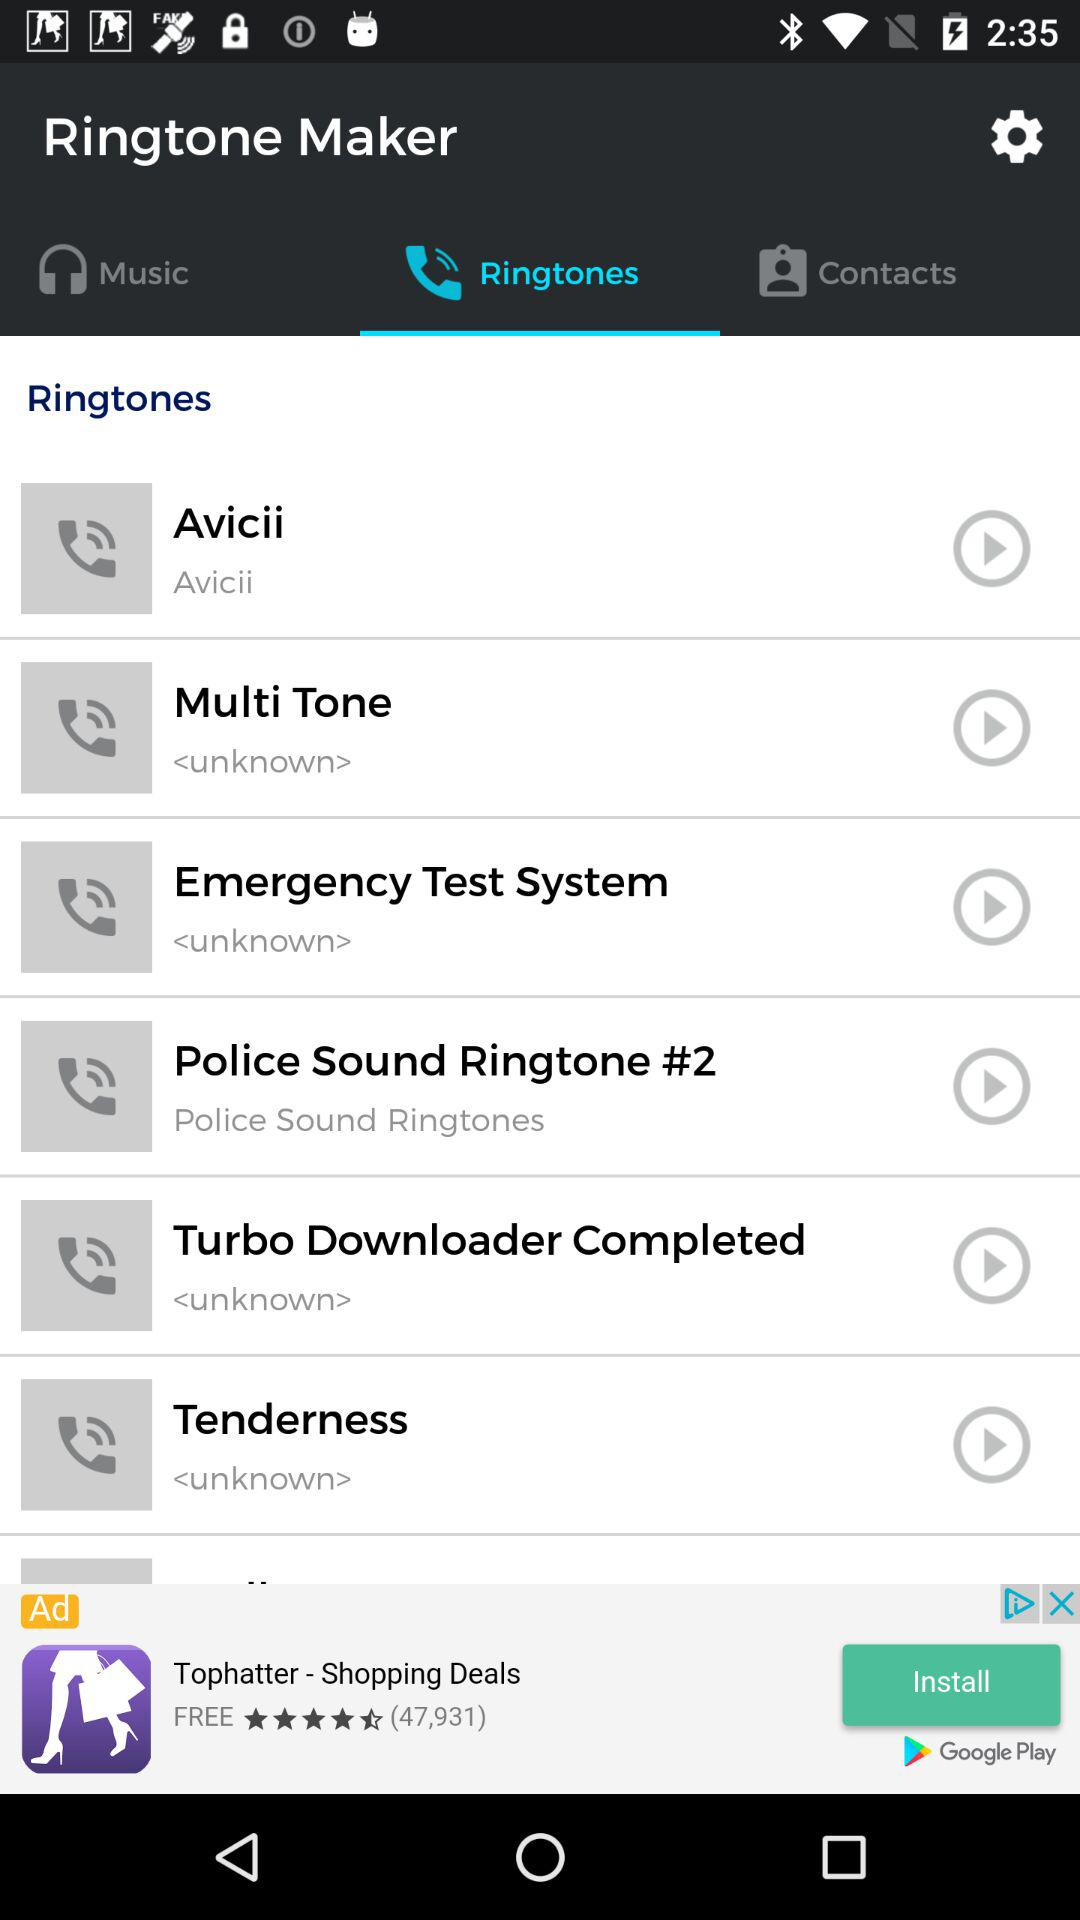How many ringtones are there?
Answer the question using a single word or phrase. 6 